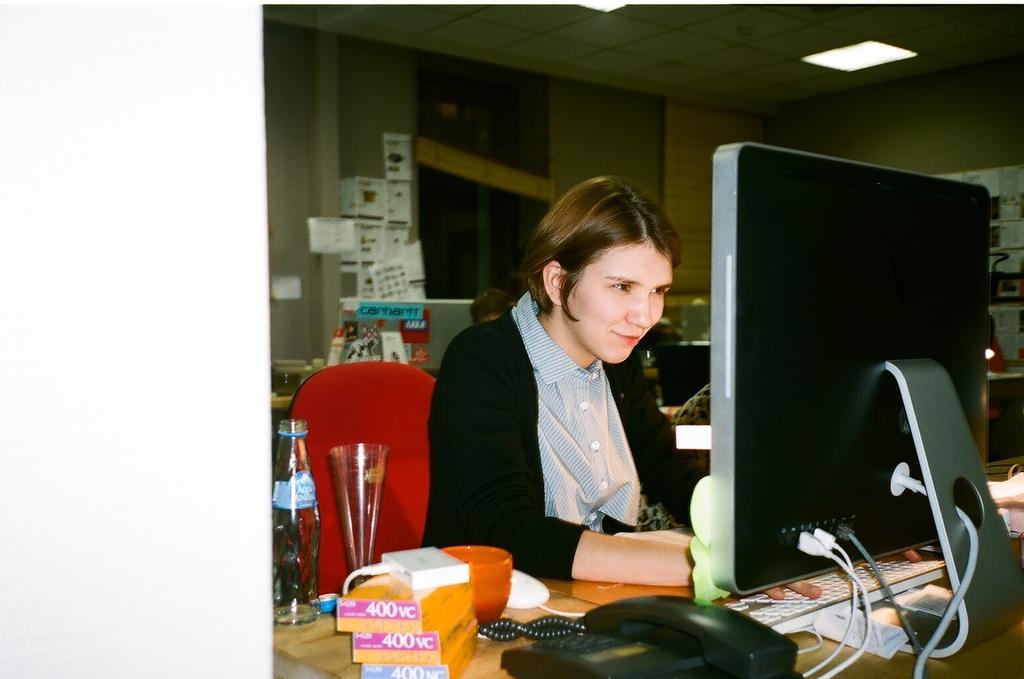Please provide a concise description of this image. As we can see in the image there is a wall, chair, table, laptop and a woman sitting on chair. On table there is a telephone, boxes, bowls and glasses. 